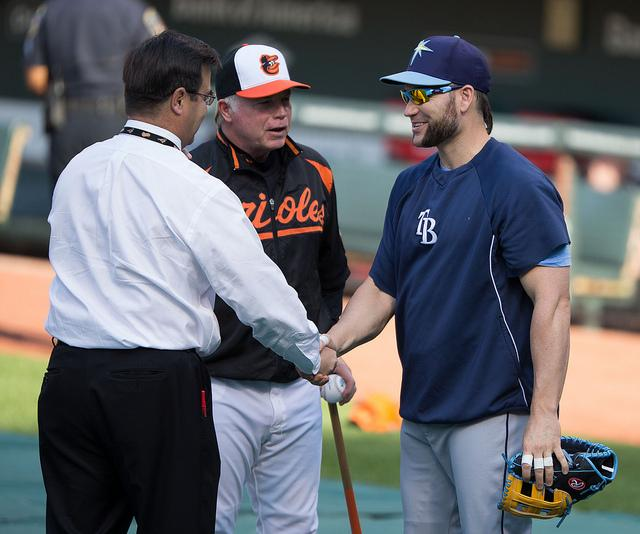Why are the men shaking hands?

Choices:
A) baseball rule
B) being friendly
C) sportsmanship
D) distraction sportsmanship 